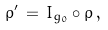<formula> <loc_0><loc_0><loc_500><loc_500>\rho ^ { \prime } \, = \, I _ { g _ { 0 } } \circ \rho \, ,</formula> 